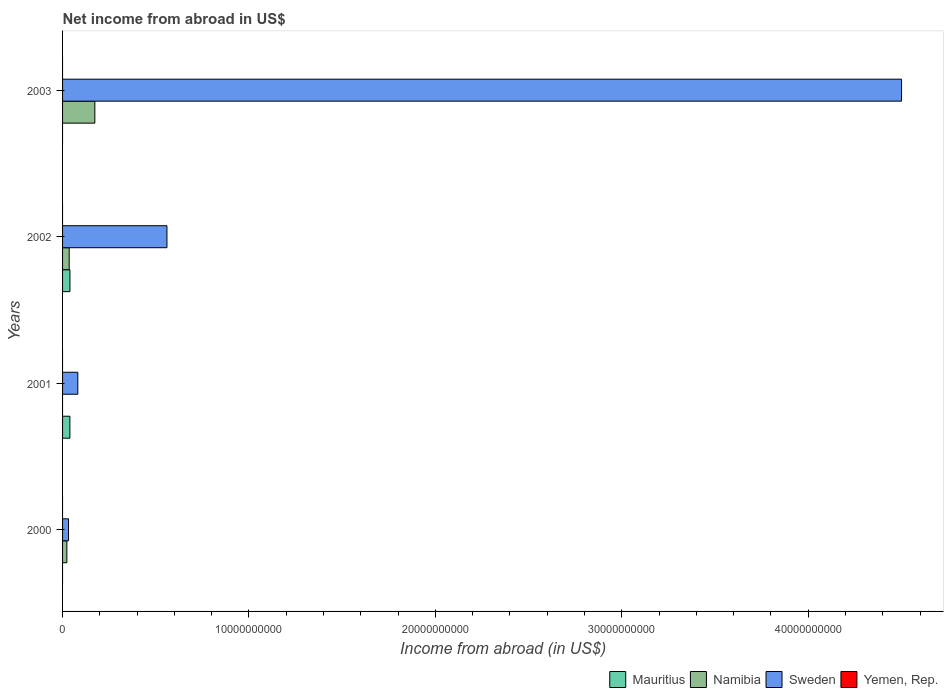How many groups of bars are there?
Your answer should be compact. 4. Are the number of bars per tick equal to the number of legend labels?
Ensure brevity in your answer.  No. Are the number of bars on each tick of the Y-axis equal?
Give a very brief answer. No. How many bars are there on the 2nd tick from the top?
Keep it short and to the point. 3. How many bars are there on the 4th tick from the bottom?
Make the answer very short. 2. What is the net income from abroad in Sweden in 2003?
Give a very brief answer. 4.50e+1. Across all years, what is the maximum net income from abroad in Sweden?
Make the answer very short. 4.50e+1. In which year was the net income from abroad in Namibia maximum?
Provide a short and direct response. 2003. What is the total net income from abroad in Namibia in the graph?
Offer a very short reply. 2.32e+09. What is the difference between the net income from abroad in Sweden in 2000 and that in 2002?
Your answer should be compact. -5.28e+09. What is the difference between the net income from abroad in Namibia in 2000 and the net income from abroad in Yemen, Rep. in 2002?
Your response must be concise. 2.30e+08. What is the average net income from abroad in Sweden per year?
Give a very brief answer. 1.29e+1. In the year 2001, what is the difference between the net income from abroad in Sweden and net income from abroad in Mauritius?
Make the answer very short. 4.25e+08. In how many years, is the net income from abroad in Sweden greater than 12000000000 US$?
Your answer should be very brief. 1. What is the ratio of the net income from abroad in Sweden in 2002 to that in 2003?
Provide a succinct answer. 0.12. Is the difference between the net income from abroad in Sweden in 2001 and 2002 greater than the difference between the net income from abroad in Mauritius in 2001 and 2002?
Give a very brief answer. No. What is the difference between the highest and the second highest net income from abroad in Namibia?
Offer a terse response. 1.38e+09. What is the difference between the highest and the lowest net income from abroad in Mauritius?
Your answer should be compact. 3.96e+08. Is it the case that in every year, the sum of the net income from abroad in Yemen, Rep. and net income from abroad in Namibia is greater than the sum of net income from abroad in Sweden and net income from abroad in Mauritius?
Your answer should be compact. No. Are all the bars in the graph horizontal?
Your answer should be compact. Yes. What is the difference between two consecutive major ticks on the X-axis?
Provide a succinct answer. 1.00e+1. Where does the legend appear in the graph?
Offer a very short reply. Bottom right. How are the legend labels stacked?
Provide a succinct answer. Horizontal. What is the title of the graph?
Ensure brevity in your answer.  Net income from abroad in US$. What is the label or title of the X-axis?
Your answer should be compact. Income from abroad (in US$). What is the Income from abroad (in US$) of Mauritius in 2000?
Offer a very short reply. 0. What is the Income from abroad (in US$) in Namibia in 2000?
Your answer should be very brief. 2.30e+08. What is the Income from abroad (in US$) of Sweden in 2000?
Your response must be concise. 3.20e+08. What is the Income from abroad (in US$) in Yemen, Rep. in 2000?
Make the answer very short. 0. What is the Income from abroad (in US$) of Mauritius in 2001?
Your response must be concise. 3.93e+08. What is the Income from abroad (in US$) of Namibia in 2001?
Keep it short and to the point. 0. What is the Income from abroad (in US$) in Sweden in 2001?
Provide a short and direct response. 8.18e+08. What is the Income from abroad (in US$) of Mauritius in 2002?
Ensure brevity in your answer.  3.96e+08. What is the Income from abroad (in US$) in Namibia in 2002?
Your answer should be very brief. 3.56e+08. What is the Income from abroad (in US$) of Sweden in 2002?
Offer a terse response. 5.60e+09. What is the Income from abroad (in US$) of Yemen, Rep. in 2002?
Give a very brief answer. 0. What is the Income from abroad (in US$) in Mauritius in 2003?
Your answer should be compact. 0. What is the Income from abroad (in US$) in Namibia in 2003?
Make the answer very short. 1.73e+09. What is the Income from abroad (in US$) in Sweden in 2003?
Provide a succinct answer. 4.50e+1. Across all years, what is the maximum Income from abroad (in US$) of Mauritius?
Keep it short and to the point. 3.96e+08. Across all years, what is the maximum Income from abroad (in US$) in Namibia?
Your response must be concise. 1.73e+09. Across all years, what is the maximum Income from abroad (in US$) of Sweden?
Offer a very short reply. 4.50e+1. Across all years, what is the minimum Income from abroad (in US$) in Namibia?
Keep it short and to the point. 0. Across all years, what is the minimum Income from abroad (in US$) of Sweden?
Offer a very short reply. 3.20e+08. What is the total Income from abroad (in US$) in Mauritius in the graph?
Make the answer very short. 7.89e+08. What is the total Income from abroad (in US$) in Namibia in the graph?
Offer a terse response. 2.32e+09. What is the total Income from abroad (in US$) of Sweden in the graph?
Offer a terse response. 5.17e+1. What is the total Income from abroad (in US$) of Yemen, Rep. in the graph?
Make the answer very short. 0. What is the difference between the Income from abroad (in US$) in Sweden in 2000 and that in 2001?
Offer a very short reply. -4.98e+08. What is the difference between the Income from abroad (in US$) of Namibia in 2000 and that in 2002?
Offer a very short reply. -1.26e+08. What is the difference between the Income from abroad (in US$) of Sweden in 2000 and that in 2002?
Ensure brevity in your answer.  -5.28e+09. What is the difference between the Income from abroad (in US$) of Namibia in 2000 and that in 2003?
Make the answer very short. -1.50e+09. What is the difference between the Income from abroad (in US$) of Sweden in 2000 and that in 2003?
Make the answer very short. -4.47e+1. What is the difference between the Income from abroad (in US$) of Mauritius in 2001 and that in 2002?
Keep it short and to the point. -3.00e+06. What is the difference between the Income from abroad (in US$) in Sweden in 2001 and that in 2002?
Make the answer very short. -4.78e+09. What is the difference between the Income from abroad (in US$) of Sweden in 2001 and that in 2003?
Your response must be concise. -4.42e+1. What is the difference between the Income from abroad (in US$) of Namibia in 2002 and that in 2003?
Make the answer very short. -1.38e+09. What is the difference between the Income from abroad (in US$) in Sweden in 2002 and that in 2003?
Keep it short and to the point. -3.94e+1. What is the difference between the Income from abroad (in US$) of Namibia in 2000 and the Income from abroad (in US$) of Sweden in 2001?
Your answer should be very brief. -5.88e+08. What is the difference between the Income from abroad (in US$) of Namibia in 2000 and the Income from abroad (in US$) of Sweden in 2002?
Your response must be concise. -5.37e+09. What is the difference between the Income from abroad (in US$) in Namibia in 2000 and the Income from abroad (in US$) in Sweden in 2003?
Your response must be concise. -4.48e+1. What is the difference between the Income from abroad (in US$) in Mauritius in 2001 and the Income from abroad (in US$) in Namibia in 2002?
Keep it short and to the point. 3.69e+07. What is the difference between the Income from abroad (in US$) of Mauritius in 2001 and the Income from abroad (in US$) of Sweden in 2002?
Provide a succinct answer. -5.21e+09. What is the difference between the Income from abroad (in US$) of Mauritius in 2001 and the Income from abroad (in US$) of Namibia in 2003?
Ensure brevity in your answer.  -1.34e+09. What is the difference between the Income from abroad (in US$) in Mauritius in 2001 and the Income from abroad (in US$) in Sweden in 2003?
Offer a very short reply. -4.46e+1. What is the difference between the Income from abroad (in US$) of Mauritius in 2002 and the Income from abroad (in US$) of Namibia in 2003?
Give a very brief answer. -1.34e+09. What is the difference between the Income from abroad (in US$) in Mauritius in 2002 and the Income from abroad (in US$) in Sweden in 2003?
Provide a succinct answer. -4.46e+1. What is the difference between the Income from abroad (in US$) in Namibia in 2002 and the Income from abroad (in US$) in Sweden in 2003?
Offer a very short reply. -4.46e+1. What is the average Income from abroad (in US$) of Mauritius per year?
Your response must be concise. 1.97e+08. What is the average Income from abroad (in US$) of Namibia per year?
Your answer should be compact. 5.80e+08. What is the average Income from abroad (in US$) of Sweden per year?
Your response must be concise. 1.29e+1. In the year 2000, what is the difference between the Income from abroad (in US$) of Namibia and Income from abroad (in US$) of Sweden?
Ensure brevity in your answer.  -8.95e+07. In the year 2001, what is the difference between the Income from abroad (in US$) in Mauritius and Income from abroad (in US$) in Sweden?
Keep it short and to the point. -4.25e+08. In the year 2002, what is the difference between the Income from abroad (in US$) in Mauritius and Income from abroad (in US$) in Namibia?
Keep it short and to the point. 3.99e+07. In the year 2002, what is the difference between the Income from abroad (in US$) of Mauritius and Income from abroad (in US$) of Sweden?
Keep it short and to the point. -5.20e+09. In the year 2002, what is the difference between the Income from abroad (in US$) in Namibia and Income from abroad (in US$) in Sweden?
Your answer should be compact. -5.24e+09. In the year 2003, what is the difference between the Income from abroad (in US$) of Namibia and Income from abroad (in US$) of Sweden?
Offer a terse response. -4.33e+1. What is the ratio of the Income from abroad (in US$) of Sweden in 2000 to that in 2001?
Make the answer very short. 0.39. What is the ratio of the Income from abroad (in US$) of Namibia in 2000 to that in 2002?
Offer a terse response. 0.65. What is the ratio of the Income from abroad (in US$) in Sweden in 2000 to that in 2002?
Provide a succinct answer. 0.06. What is the ratio of the Income from abroad (in US$) in Namibia in 2000 to that in 2003?
Keep it short and to the point. 0.13. What is the ratio of the Income from abroad (in US$) of Sweden in 2000 to that in 2003?
Your answer should be very brief. 0.01. What is the ratio of the Income from abroad (in US$) of Mauritius in 2001 to that in 2002?
Keep it short and to the point. 0.99. What is the ratio of the Income from abroad (in US$) in Sweden in 2001 to that in 2002?
Provide a short and direct response. 0.15. What is the ratio of the Income from abroad (in US$) in Sweden in 2001 to that in 2003?
Give a very brief answer. 0.02. What is the ratio of the Income from abroad (in US$) in Namibia in 2002 to that in 2003?
Your answer should be very brief. 0.21. What is the ratio of the Income from abroad (in US$) in Sweden in 2002 to that in 2003?
Offer a very short reply. 0.12. What is the difference between the highest and the second highest Income from abroad (in US$) of Namibia?
Keep it short and to the point. 1.38e+09. What is the difference between the highest and the second highest Income from abroad (in US$) in Sweden?
Your response must be concise. 3.94e+1. What is the difference between the highest and the lowest Income from abroad (in US$) in Mauritius?
Provide a short and direct response. 3.96e+08. What is the difference between the highest and the lowest Income from abroad (in US$) of Namibia?
Provide a short and direct response. 1.73e+09. What is the difference between the highest and the lowest Income from abroad (in US$) in Sweden?
Provide a succinct answer. 4.47e+1. 